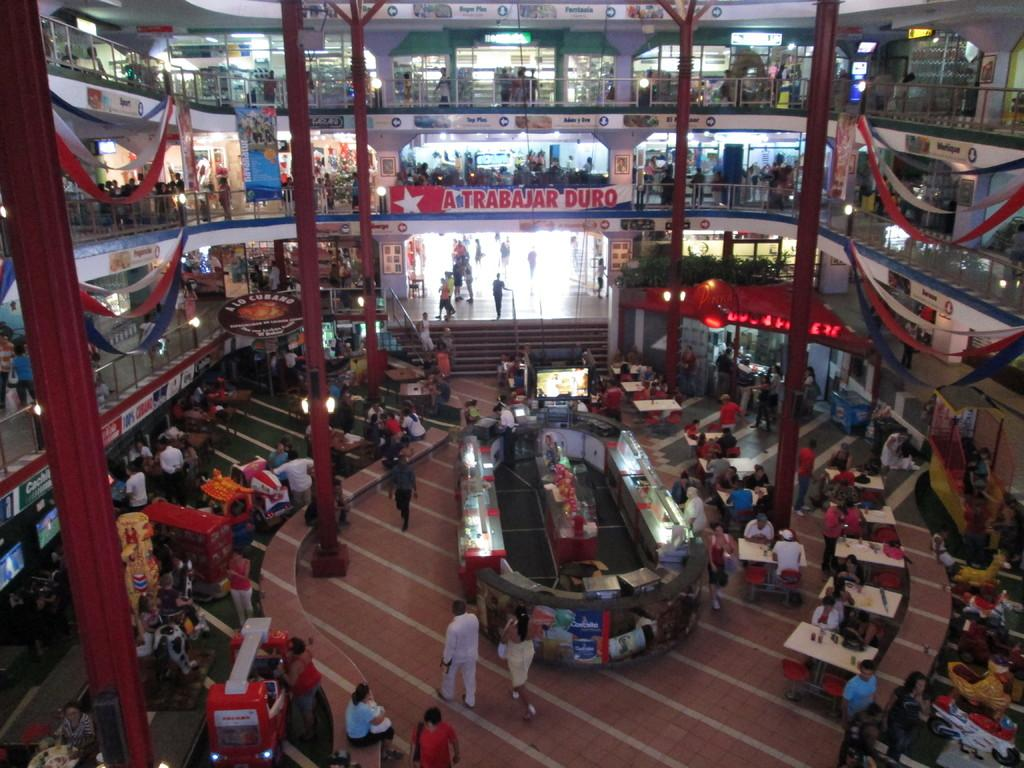Where was the image taken? The image was taken in a mall. What architectural features can be seen in the image? There are pillars in the image. Are there any people present in the image? Yes, there are persons in the image. What type of furniture is visible in the image? There are tables in the image. What type of flooring is present in the image? There are floors in the image. What type of decorations can be seen in the image? There are flags in the image. What type of commercial establishments are present in the image? There are stores in the image. What type of signage is visible in the image? There is a banner in the image. What type of accessibility feature is present in the image? There are stairs in the image. What type of identification is present in the image? There is a name board in the image. What type of wing can be seen flying in the image? There are no wings or flying creatures visible in the image. 